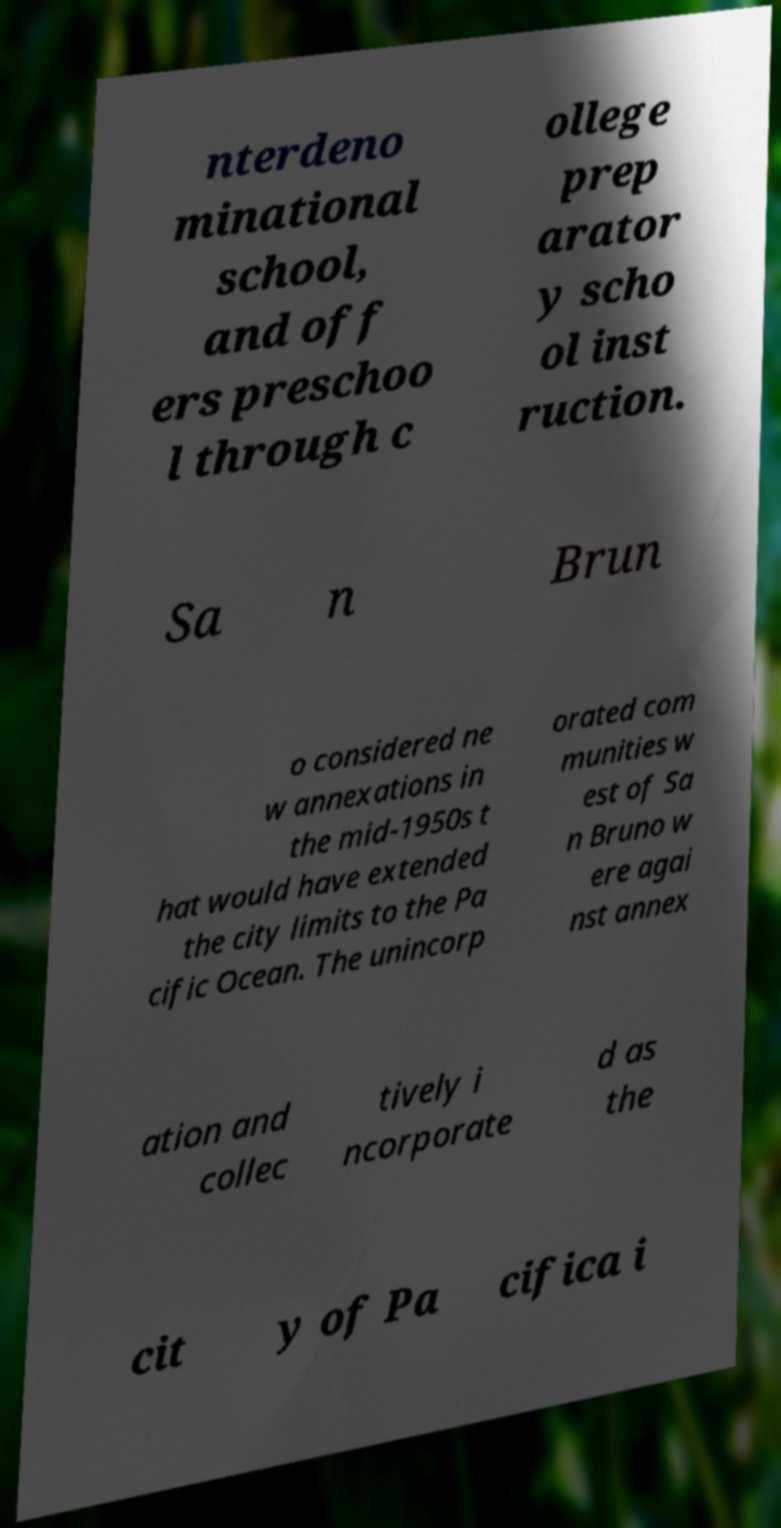For documentation purposes, I need the text within this image transcribed. Could you provide that? nterdeno minational school, and off ers preschoo l through c ollege prep arator y scho ol inst ruction. Sa n Brun o considered ne w annexations in the mid-1950s t hat would have extended the city limits to the Pa cific Ocean. The unincorp orated com munities w est of Sa n Bruno w ere agai nst annex ation and collec tively i ncorporate d as the cit y of Pa cifica i 